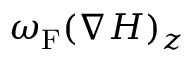Convert formula to latex. <formula><loc_0><loc_0><loc_500><loc_500>\omega _ { F } ( \nabla H ) _ { z }</formula> 